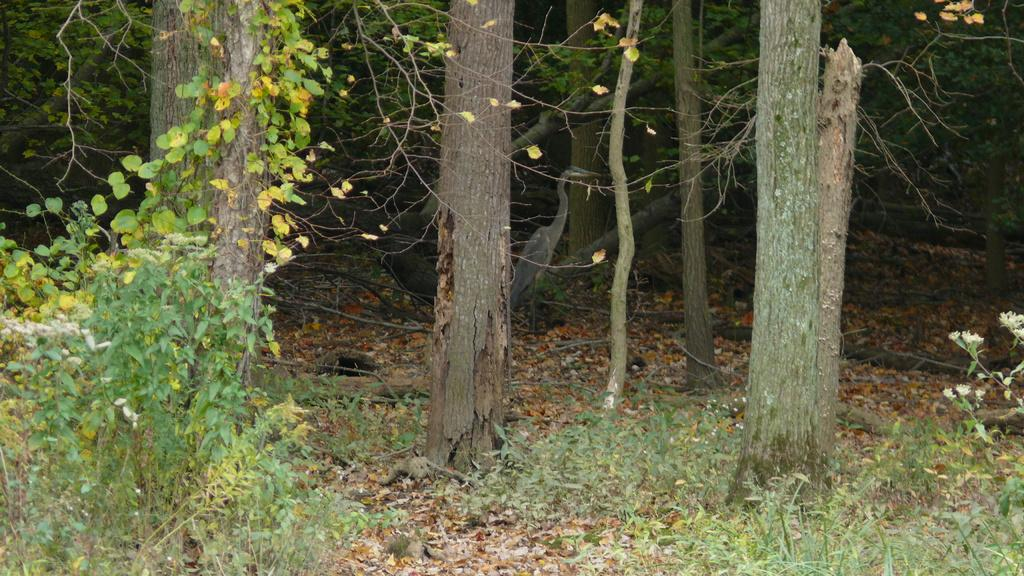What type of vegetation is present in the image? There are trees and plants in the image. Can you describe the bird in the image? There is a bird on the ground in the image. What type of joke is the committee telling in the image? There is no committee or joke present in the image; it features trees, plants, and a bird on the ground. Can you tell me how many rabbits are visible in the image? There are no rabbits present in the image. 